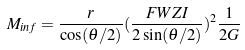Convert formula to latex. <formula><loc_0><loc_0><loc_500><loc_500>M _ { i n f } = \frac { r } { \cos ( \theta / 2 ) } ( \frac { F W Z I } { 2 \sin ( \theta / 2 ) } ) ^ { 2 } \frac { 1 } { 2 G }</formula> 